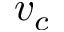<formula> <loc_0><loc_0><loc_500><loc_500>v _ { c }</formula> 